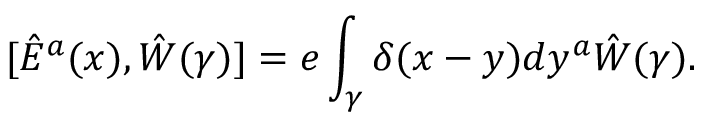Convert formula to latex. <formula><loc_0><loc_0><loc_500><loc_500>[ \hat { E } ^ { a } ( x ) , \hat { W } ( \gamma ) ] = e \int _ { \gamma } \delta ( x - y ) d y ^ { a } \hat { W } ( \gamma ) .</formula> 